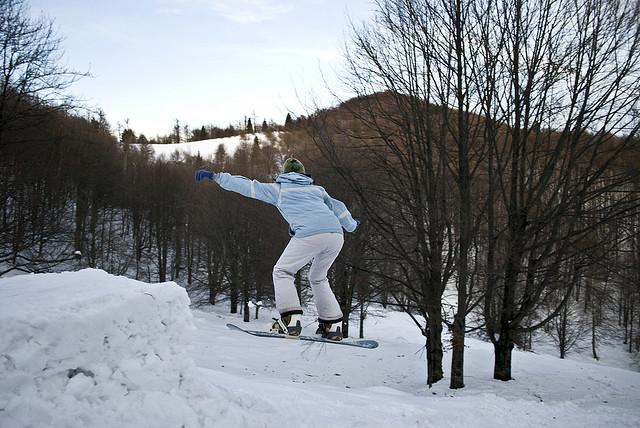What is there many of?
Give a very brief answer. Trees. Does this person look in the air or on the ground?
Concise answer only. Air. Isn't she too close to the trees?
Keep it brief. No. Is this person skiing or snowboarding?
Give a very brief answer. Snowboarding. What type of trees is the lady leaning against?
Quick response, please. Oak. 